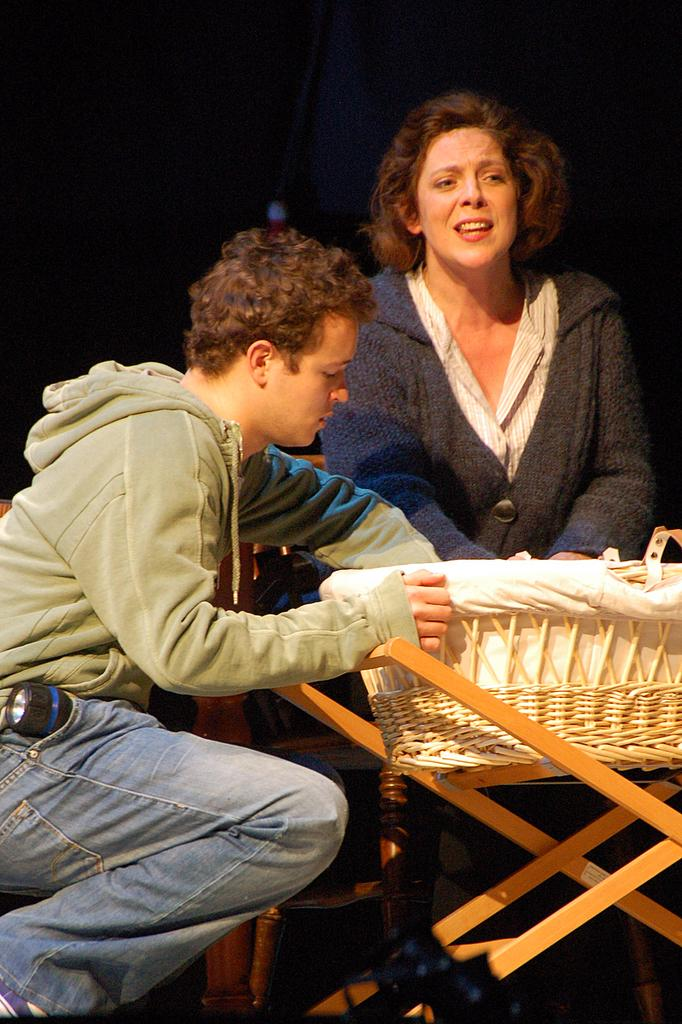How many people are in the image? There are two people in the image. What are the two people doing in the image? The two people are sitting. Where are the two people sitting? They are sitting in front of a table. What can be seen on the table in the image? There are baskets on the table. What type of poison is being used by the people in the image? There is no poison present in the image; the two people are simply sitting in front of a table. 